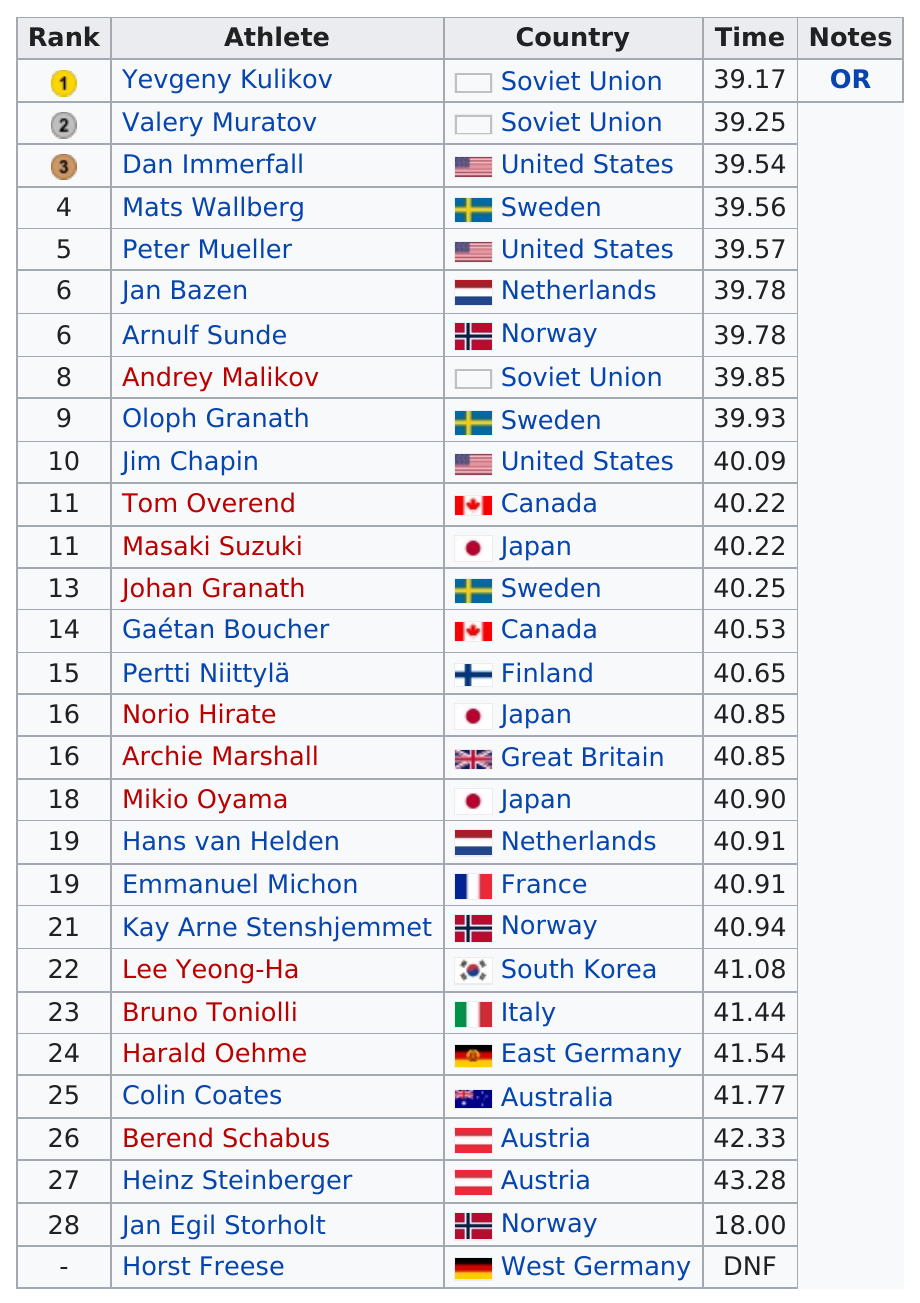Mention a couple of crucial points in this snapshot. I'm sorry, but the sentence you provided is not grammatically correct and is difficult to understand. Can you please provide more context or clarify your question? Arnulf Sunde was faster than Mikio Oyama. The competition was fierce, with 3 competitors hailing from the Soviet Union. Nine racers finished the course in under forty seconds. Of the racers participating, only 1 did not finish. 